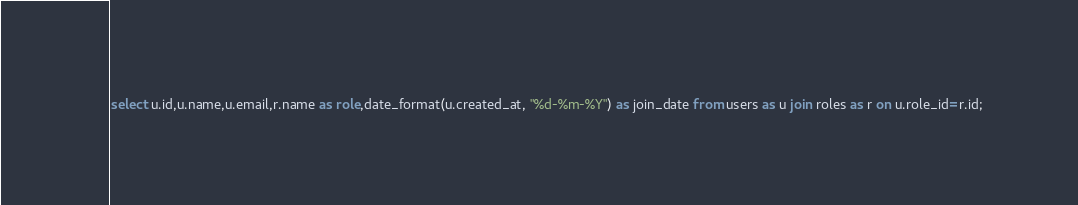Convert code to text. <code><loc_0><loc_0><loc_500><loc_500><_SQL_>select u.id,u.name,u.email,r.name as role,date_format(u.created_at, "%d-%m-%Y") as join_date from users as u join roles as r on u.role_id=r.id;
</code> 